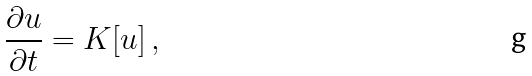Convert formula to latex. <formula><loc_0><loc_0><loc_500><loc_500>\frac { \partial u } { \partial t } = K [ u ] \, ,</formula> 